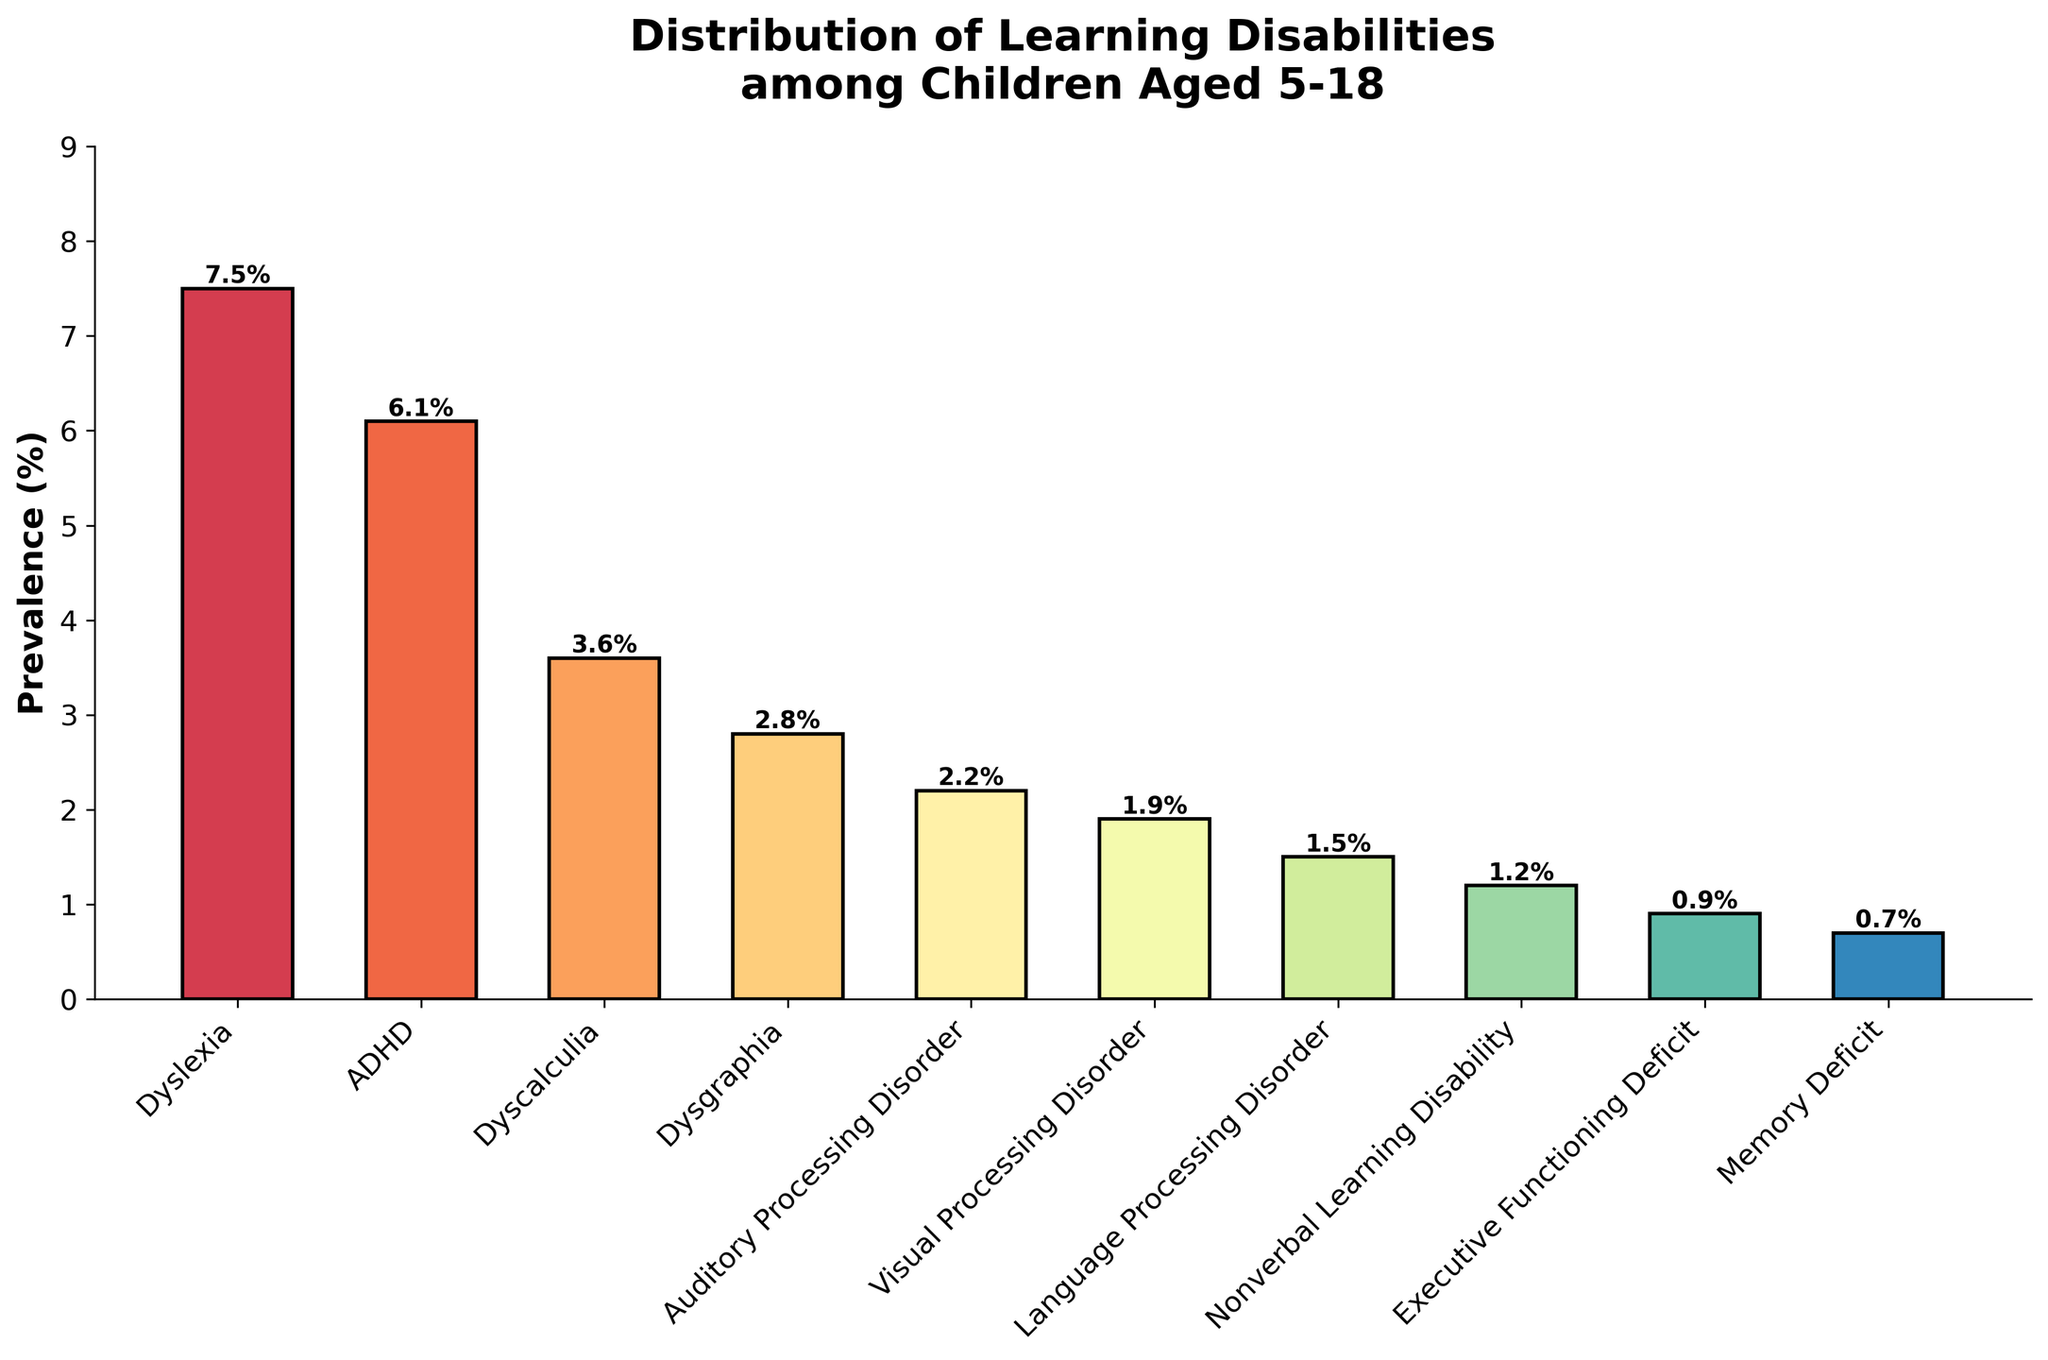What's the most prevalent learning disability among children aged 5-18? The bar representing Dyslexia has the highest height among all bars, indicating it has the highest prevalence rate. Simply observing the tallest bar provides the answer.
Answer: Dyslexia How much more prevalent is ADHD compared to Dyscalculia? ADHD has a prevalence rate of 6.1%, and Dyscalculia has a prevalence rate of 3.6%. Subtracting the prevalence of Dyscalculia from ADHD gives 6.1% - 3.6% = 2.5%.
Answer: 2.5% What is the combined prevalence of Dyslexia and ADHD? The prevalence of Dyslexia is 7.5%, and the prevalence of ADHD is 6.1%. Adding these together gives 7.5% + 6.1% = 13.6%.
Answer: 13.6% Which learning disability has a prevalence slightly above 2% but less than 3%? By checking the labels and their corresponding heights, Dysgraphia at 2.8% fits this description.
Answer: Dysgraphia What is the smallest prevalence rate shown on the chart? By observing the shortest bar, it represents the Memory Deficit, which has a prevalence rate of 0.7%.
Answer: 0.7% What is the prevalence difference between Dyslexia and Language Processing Disorder? Dyslexia has a prevalence of 7.5% and Language Processing Disorder has a prevalence of 1.5%. Subtracting these gives 7.5% - 1.5% = 6.0%.
Answer: 6.0% Which learning disabilities have a prevalence of less than 2%? The disabilities with bars shorter than the 2% mark are Visual Processing Disorder (1.9%), Language Processing Disorder (1.5%), Nonverbal Learning Disability (1.2%), Executive Functioning Deficit (0.9%), and Memory Deficit (0.7%).
Answer: Visual Processing Disorder, Language Processing Disorder, Nonverbal Learning Disability, Executive Functioning Deficit, and Memory Deficit How does the prevalence of Auditory Processing Disorder compare with that of Visual Processing Disorder? Auditory Processing Disorder has a prevalence of 2.2%, and Visual Processing Disorder has a prevalence of 1.9%. Auditory Processing Disorder is more prevalent.
Answer: Auditory Processing Disorder is more prevalent Arrange the learning disabilities in descending order of their prevalence. Listing the disabilities by descending bar heights: Dyslexia (7.5%), ADHD (6.1%), Dyscalculia (3.6%), Dysgraphia (2.8%), Auditory Processing Disorder (2.2%), Visual Processing Disorder (1.9%), Language Processing Disorder (1.5%), Nonverbal Learning Disability (1.2%), Executive Functioning Deficit (0.9%), and Memory Deficit (0.7%).
Answer: Dyslexia, ADHD, Dyscalculia, Dysgraphia, Auditory Processing Disorder, Visual Processing Disorder, Language Processing Disorder, Nonverbal Learning Disability, Executive Functioning Deficit, Memory Deficit 